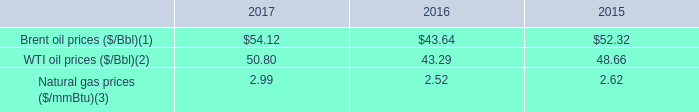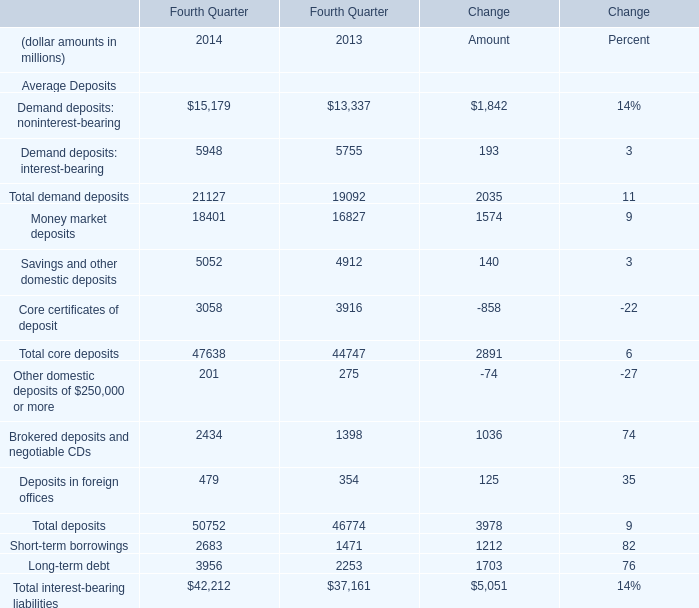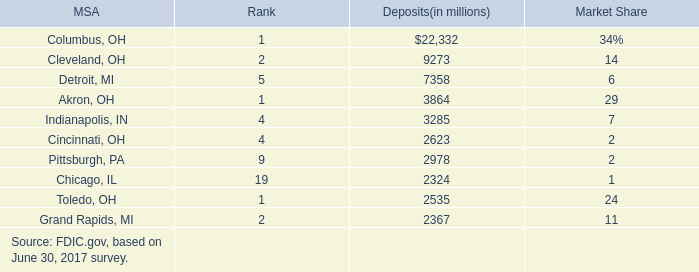What was the total amount of Core certificates of deposit, Total core deposits, Other domestic deposits of $250,000 or more and Brokered deposits and negotiable CDs in 2013? (in million) 
Computations: (((1398 + 275) + 44747) + 3916)
Answer: 50336.0. 